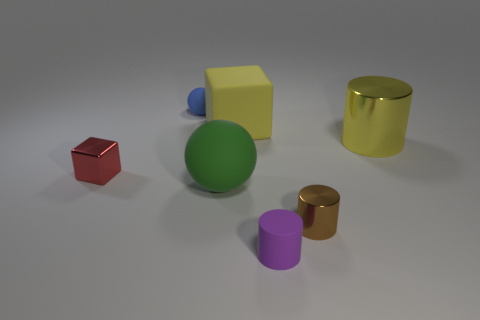Add 1 green matte spheres. How many objects exist? 8 Subtract all cylinders. How many objects are left? 4 Add 6 yellow blocks. How many yellow blocks exist? 7 Subtract 0 gray cylinders. How many objects are left? 7 Subtract all small blue spheres. Subtract all rubber objects. How many objects are left? 2 Add 1 small brown things. How many small brown things are left? 2 